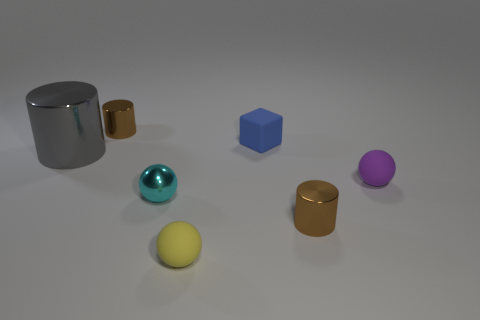How many objects in the image have reflective surfaces? In the image, there are three objects with reflective surfaces. These include the large cylinder, the small teal sphere, and one of the small cylinders, all of which exhibit a degree of shininess indicative of reflective material. 